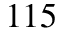Convert formula to latex. <formula><loc_0><loc_0><loc_500><loc_500>1 1 5</formula> 